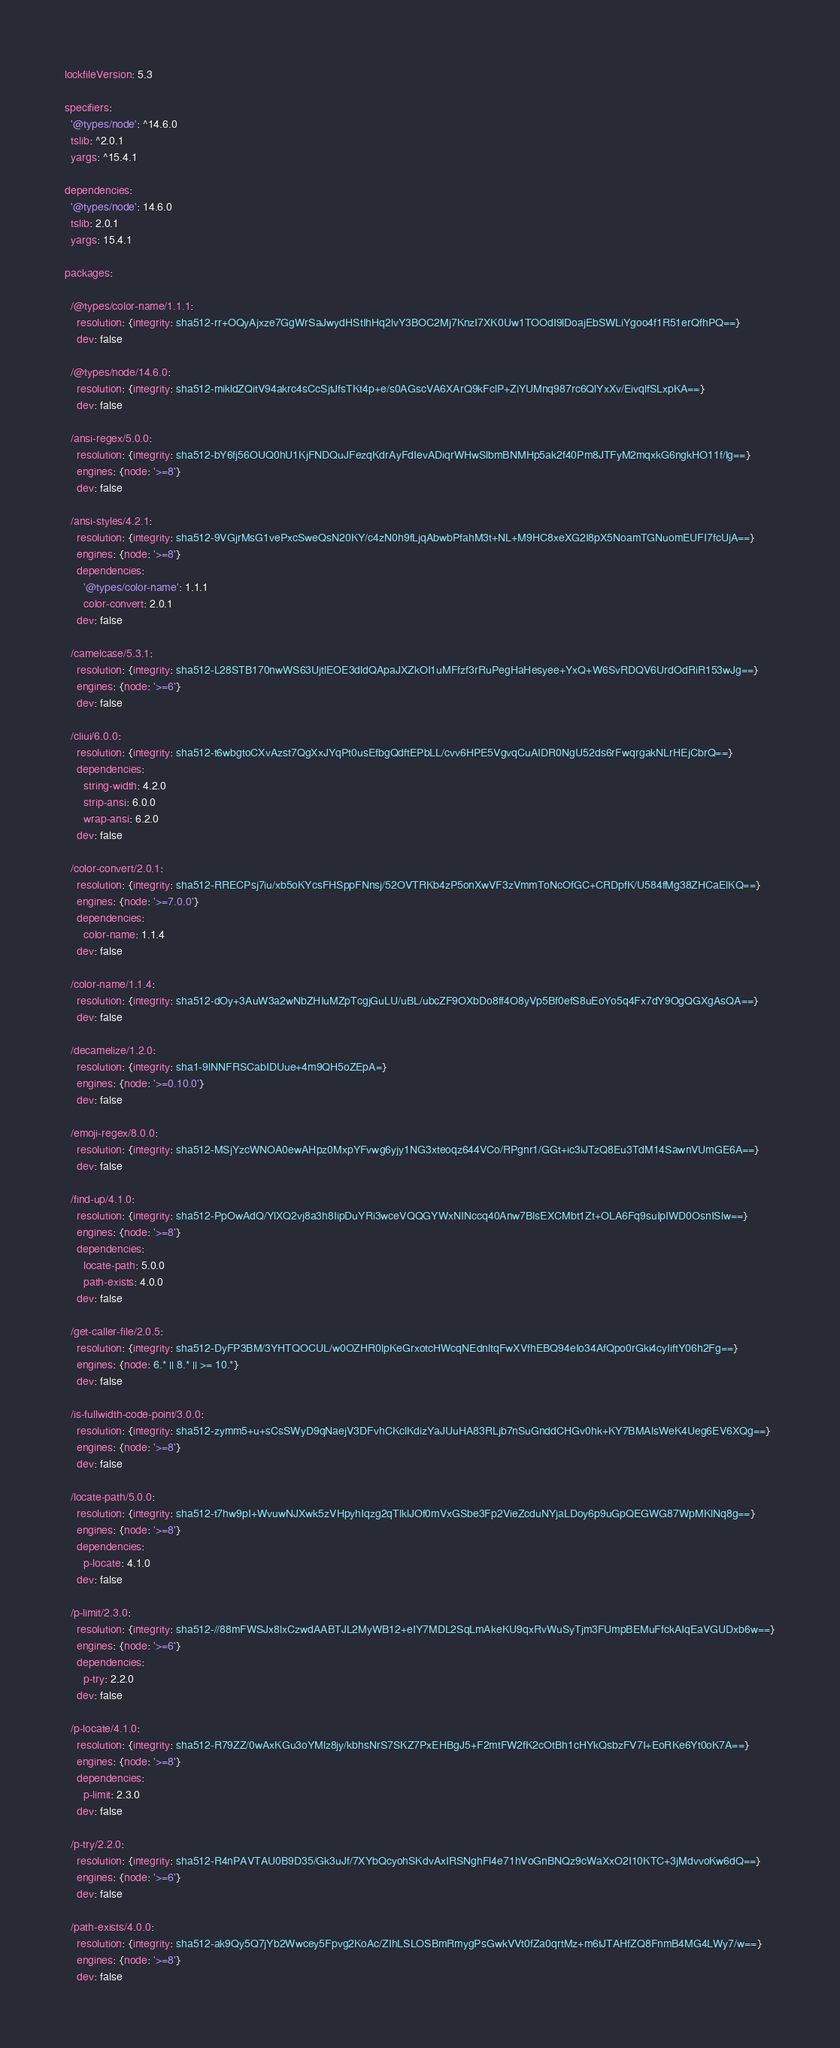Convert code to text. <code><loc_0><loc_0><loc_500><loc_500><_YAML_>lockfileVersion: 5.3

specifiers:
  '@types/node': ^14.6.0
  tslib: ^2.0.1
  yargs: ^15.4.1

dependencies:
  '@types/node': 14.6.0
  tslib: 2.0.1
  yargs: 15.4.1

packages:

  /@types/color-name/1.1.1:
    resolution: {integrity: sha512-rr+OQyAjxze7GgWrSaJwydHStIhHq2lvY3BOC2Mj7KnzI7XK0Uw1TOOdI9lDoajEbSWLiYgoo4f1R51erQfhPQ==}
    dev: false

  /@types/node/14.6.0:
    resolution: {integrity: sha512-mikldZQitV94akrc4sCcSjtJfsTKt4p+e/s0AGscVA6XArQ9kFclP+ZiYUMnq987rc6QlYxXv/EivqlfSLxpKA==}
    dev: false

  /ansi-regex/5.0.0:
    resolution: {integrity: sha512-bY6fj56OUQ0hU1KjFNDQuJFezqKdrAyFdIevADiqrWHwSlbmBNMHp5ak2f40Pm8JTFyM2mqxkG6ngkHO11f/lg==}
    engines: {node: '>=8'}
    dev: false

  /ansi-styles/4.2.1:
    resolution: {integrity: sha512-9VGjrMsG1vePxcSweQsN20KY/c4zN0h9fLjqAbwbPfahM3t+NL+M9HC8xeXG2I8pX5NoamTGNuomEUFI7fcUjA==}
    engines: {node: '>=8'}
    dependencies:
      '@types/color-name': 1.1.1
      color-convert: 2.0.1
    dev: false

  /camelcase/5.3.1:
    resolution: {integrity: sha512-L28STB170nwWS63UjtlEOE3dldQApaJXZkOI1uMFfzf3rRuPegHaHesyee+YxQ+W6SvRDQV6UrdOdRiR153wJg==}
    engines: {node: '>=6'}
    dev: false

  /cliui/6.0.0:
    resolution: {integrity: sha512-t6wbgtoCXvAzst7QgXxJYqPt0usEfbgQdftEPbLL/cvv6HPE5VgvqCuAIDR0NgU52ds6rFwqrgakNLrHEjCbrQ==}
    dependencies:
      string-width: 4.2.0
      strip-ansi: 6.0.0
      wrap-ansi: 6.2.0
    dev: false

  /color-convert/2.0.1:
    resolution: {integrity: sha512-RRECPsj7iu/xb5oKYcsFHSppFNnsj/52OVTRKb4zP5onXwVF3zVmmToNcOfGC+CRDpfK/U584fMg38ZHCaElKQ==}
    engines: {node: '>=7.0.0'}
    dependencies:
      color-name: 1.1.4
    dev: false

  /color-name/1.1.4:
    resolution: {integrity: sha512-dOy+3AuW3a2wNbZHIuMZpTcgjGuLU/uBL/ubcZF9OXbDo8ff4O8yVp5Bf0efS8uEoYo5q4Fx7dY9OgQGXgAsQA==}
    dev: false

  /decamelize/1.2.0:
    resolution: {integrity: sha1-9lNNFRSCabIDUue+4m9QH5oZEpA=}
    engines: {node: '>=0.10.0'}
    dev: false

  /emoji-regex/8.0.0:
    resolution: {integrity: sha512-MSjYzcWNOA0ewAHpz0MxpYFvwg6yjy1NG3xteoqz644VCo/RPgnr1/GGt+ic3iJTzQ8Eu3TdM14SawnVUmGE6A==}
    dev: false

  /find-up/4.1.0:
    resolution: {integrity: sha512-PpOwAdQ/YlXQ2vj8a3h8IipDuYRi3wceVQQGYWxNINccq40Anw7BlsEXCMbt1Zt+OLA6Fq9suIpIWD0OsnISlw==}
    engines: {node: '>=8'}
    dependencies:
      locate-path: 5.0.0
      path-exists: 4.0.0
    dev: false

  /get-caller-file/2.0.5:
    resolution: {integrity: sha512-DyFP3BM/3YHTQOCUL/w0OZHR0lpKeGrxotcHWcqNEdnltqFwXVfhEBQ94eIo34AfQpo0rGki4cyIiftY06h2Fg==}
    engines: {node: 6.* || 8.* || >= 10.*}
    dev: false

  /is-fullwidth-code-point/3.0.0:
    resolution: {integrity: sha512-zymm5+u+sCsSWyD9qNaejV3DFvhCKclKdizYaJUuHA83RLjb7nSuGnddCHGv0hk+KY7BMAlsWeK4Ueg6EV6XQg==}
    engines: {node: '>=8'}
    dev: false

  /locate-path/5.0.0:
    resolution: {integrity: sha512-t7hw9pI+WvuwNJXwk5zVHpyhIqzg2qTlklJOf0mVxGSbe3Fp2VieZcduNYjaLDoy6p9uGpQEGWG87WpMKlNq8g==}
    engines: {node: '>=8'}
    dependencies:
      p-locate: 4.1.0
    dev: false

  /p-limit/2.3.0:
    resolution: {integrity: sha512-//88mFWSJx8lxCzwdAABTJL2MyWB12+eIY7MDL2SqLmAkeKU9qxRvWuSyTjm3FUmpBEMuFfckAIqEaVGUDxb6w==}
    engines: {node: '>=6'}
    dependencies:
      p-try: 2.2.0
    dev: false

  /p-locate/4.1.0:
    resolution: {integrity: sha512-R79ZZ/0wAxKGu3oYMlz8jy/kbhsNrS7SKZ7PxEHBgJ5+F2mtFW2fK2cOtBh1cHYkQsbzFV7I+EoRKe6Yt0oK7A==}
    engines: {node: '>=8'}
    dependencies:
      p-limit: 2.3.0
    dev: false

  /p-try/2.2.0:
    resolution: {integrity: sha512-R4nPAVTAU0B9D35/Gk3uJf/7XYbQcyohSKdvAxIRSNghFl4e71hVoGnBNQz9cWaXxO2I10KTC+3jMdvvoKw6dQ==}
    engines: {node: '>=6'}
    dev: false

  /path-exists/4.0.0:
    resolution: {integrity: sha512-ak9Qy5Q7jYb2Wwcey5Fpvg2KoAc/ZIhLSLOSBmRmygPsGwkVVt0fZa0qrtMz+m6tJTAHfZQ8FnmB4MG4LWy7/w==}
    engines: {node: '>=8'}
    dev: false
</code> 